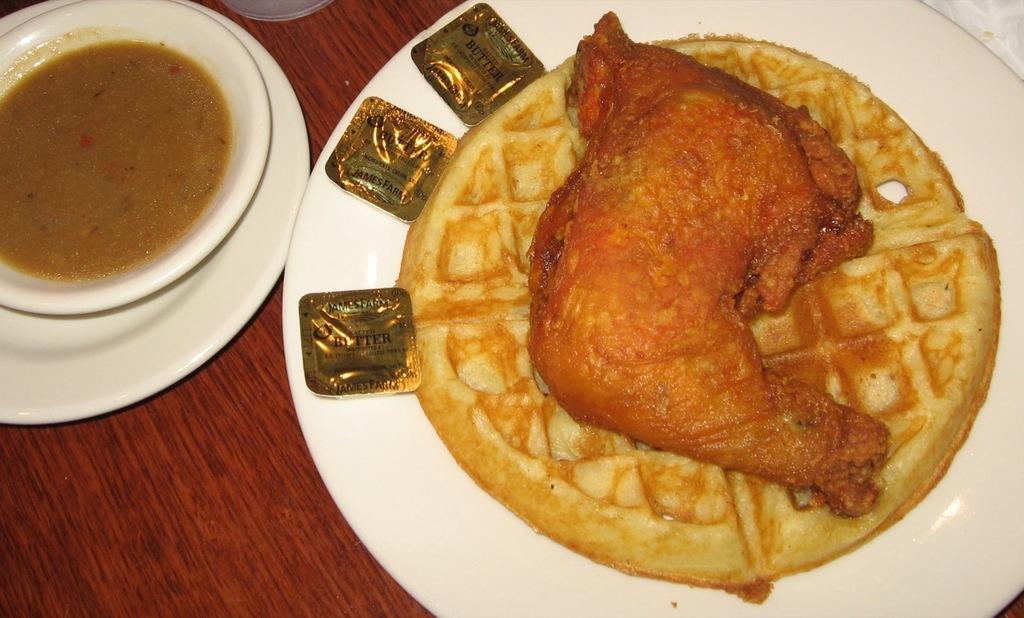Please provide a concise description of this image. In the picture I can see food items in a plate and in a bowl. I can also see a bowl on a plate. These objects are on a wooden surface. 